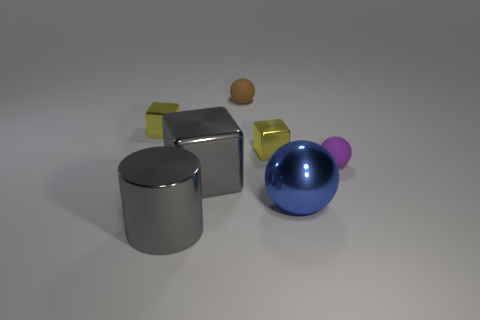Subtract all gray cubes. How many cubes are left? 2 Subtract all gray cylinders. How many yellow blocks are left? 2 Add 1 big blue rubber cubes. How many objects exist? 8 Subtract all gray blocks. How many blocks are left? 2 Subtract all spheres. How many objects are left? 4 Subtract 2 spheres. How many spheres are left? 1 Subtract 0 purple cylinders. How many objects are left? 7 Subtract all gray spheres. Subtract all red cylinders. How many spheres are left? 3 Subtract all tiny yellow shiny balls. Subtract all yellow blocks. How many objects are left? 5 Add 7 small brown matte spheres. How many small brown matte spheres are left? 8 